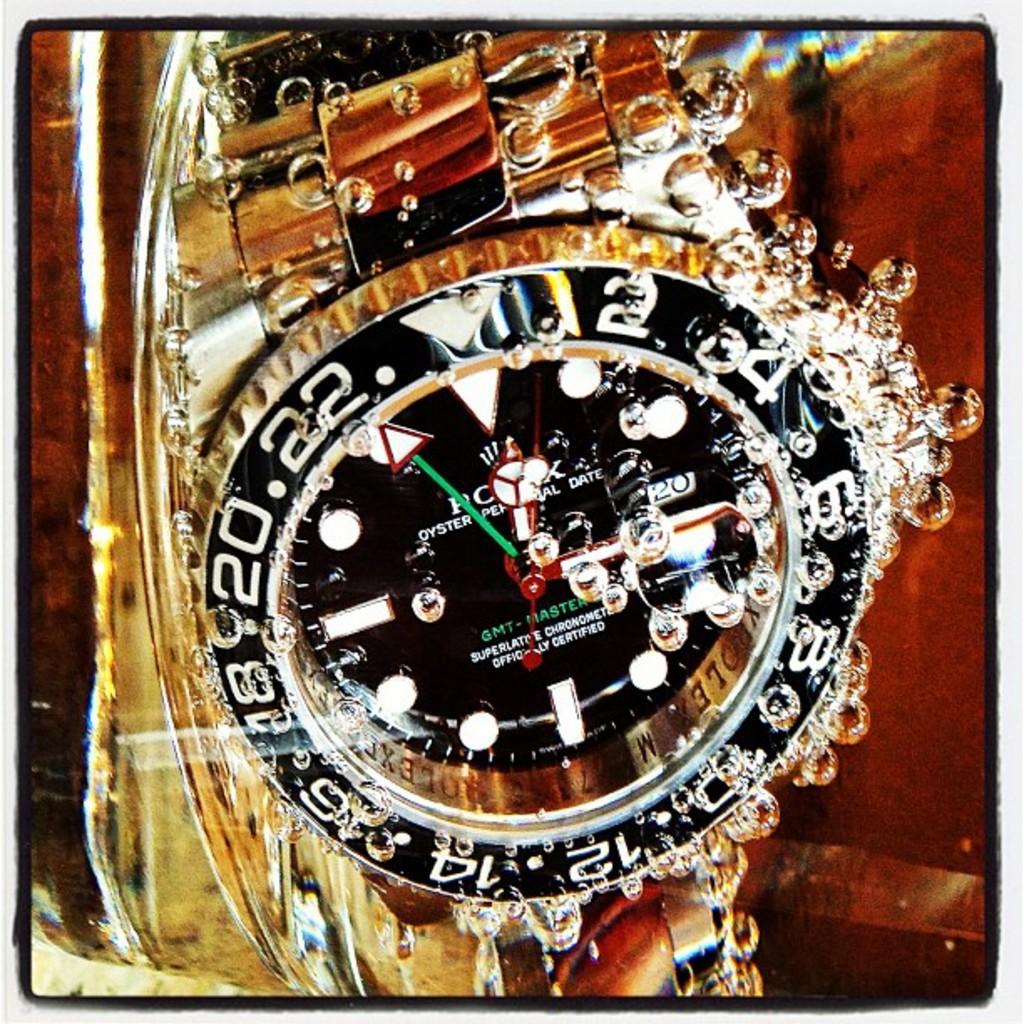What brand is the watch?
Your response must be concise. Rolex. What number does the green clock arrow point too?
Provide a short and direct response. 22. 